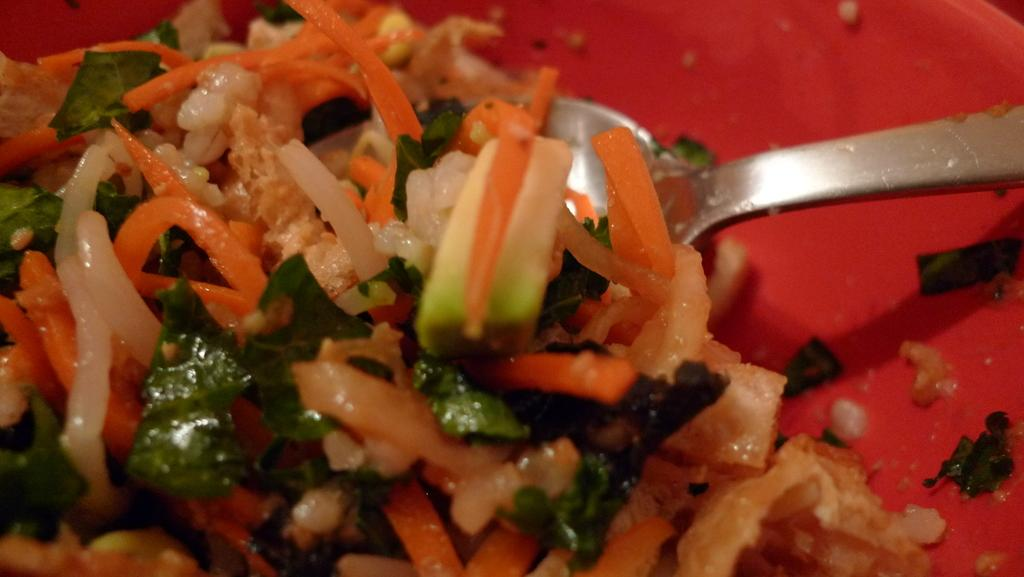What type of food items can be seen in the image? There are cut vegetables in the image. What utensil is present in the image? There is a spoon in a plate in the image. Can you describe the setting where the image might have been taken? The image may have been taken in a room. What grade does the money receive in the image? There is no money present in the image, so it is not possible to determine a grade for it. 